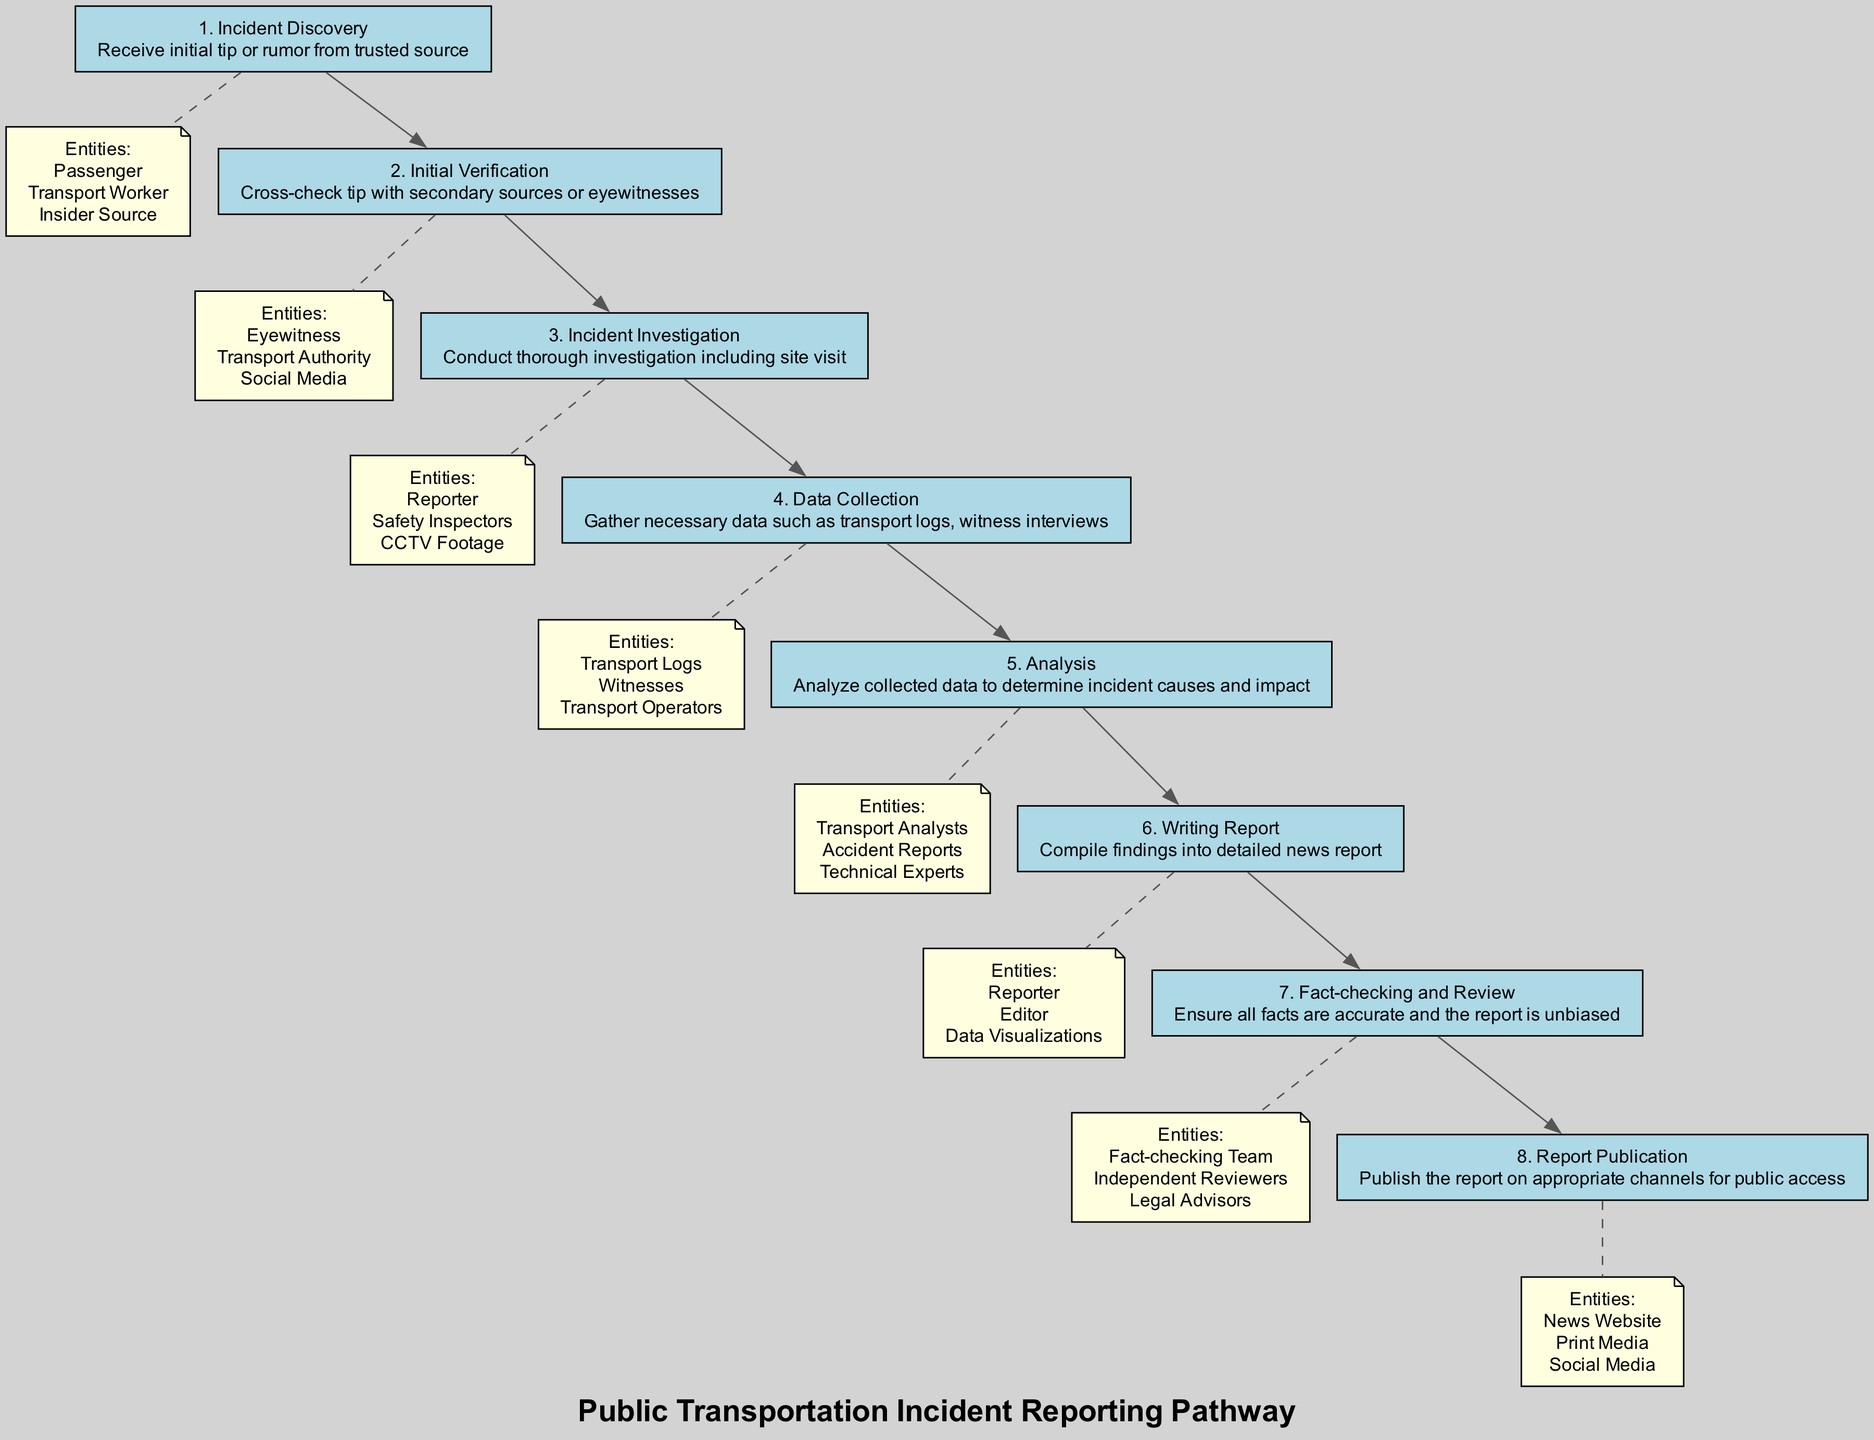What is the first step in the pathway? The first step listed in the diagram is "Incident Discovery," which indicates the initial action taken upon receiving a tip or rumor.
Answer: Incident Discovery How many steps are in the pathway? By counting the individual steps outlined in the diagram, we find there are a total of eight steps in the pathway.
Answer: 8 What is the primary entity involved in the "Incident Investigation"? The key entities listed for this step include "Reporter," "Safety Inspectors," and "CCTV Footage," with "Reporter" being the primary entity.
Answer: Reporter What relationship exists between "Data Collection" and "Analysis"? The "Data Collection" step is directly followed by the "Analysis" step, indicating that data gathered in the former is essential for conducting the latter.
Answer: Directly followed Which step involves fact-checking? The step explicitly addressing fact-checking is "Fact-checking and Review," where multiple entities ensure all facts are accurate.
Answer: Fact-checking and Review What happens immediately after "Writing Report"? The step that follows "Writing Report" is "Fact-checking and Review," which is crucial to ensure the report's accuracy before publication.
Answer: Fact-checking and Review Which entities are involved in the "Final Report" publication? The step "Report Publication" lists the entities involved, specifically "News Website," "Print Media," and "Social Media," which facilitate the distribution of the report.
Answer: News Website, Print Media, Social Media What is the last step in the reporting pathway? The final step indicated in the pathway is "Report Publication," marking the completion of the reporting process.
Answer: Report Publication Which step comes before "Data Collection"? The step directly preceding "Data Collection" is "Incident Investigation," indicating the necessary investigative work must first be completed before data can be collected.
Answer: Incident Investigation 